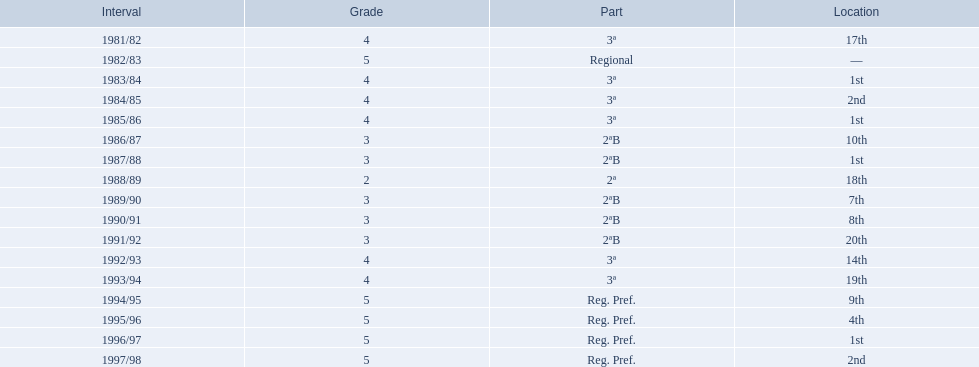What is the lowest place the team has come out? 20th. In what year did they come out in 20th place? 1991/92. 